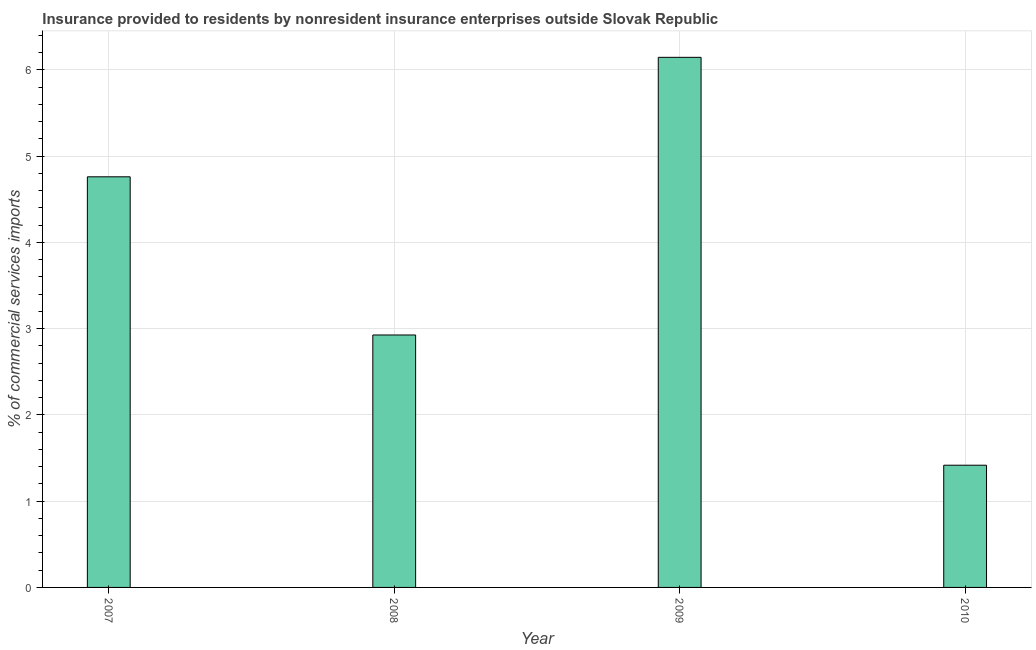Does the graph contain grids?
Keep it short and to the point. Yes. What is the title of the graph?
Your answer should be compact. Insurance provided to residents by nonresident insurance enterprises outside Slovak Republic. What is the label or title of the X-axis?
Ensure brevity in your answer.  Year. What is the label or title of the Y-axis?
Give a very brief answer. % of commercial services imports. What is the insurance provided by non-residents in 2007?
Your answer should be very brief. 4.76. Across all years, what is the maximum insurance provided by non-residents?
Keep it short and to the point. 6.15. Across all years, what is the minimum insurance provided by non-residents?
Ensure brevity in your answer.  1.42. In which year was the insurance provided by non-residents maximum?
Offer a terse response. 2009. What is the sum of the insurance provided by non-residents?
Give a very brief answer. 15.25. What is the difference between the insurance provided by non-residents in 2009 and 2010?
Keep it short and to the point. 4.73. What is the average insurance provided by non-residents per year?
Make the answer very short. 3.81. What is the median insurance provided by non-residents?
Offer a terse response. 3.84. In how many years, is the insurance provided by non-residents greater than 0.6 %?
Give a very brief answer. 4. Do a majority of the years between 2008 and 2010 (inclusive) have insurance provided by non-residents greater than 5.6 %?
Your answer should be compact. No. What is the ratio of the insurance provided by non-residents in 2009 to that in 2010?
Offer a terse response. 4.34. What is the difference between the highest and the second highest insurance provided by non-residents?
Offer a very short reply. 1.39. What is the difference between the highest and the lowest insurance provided by non-residents?
Offer a terse response. 4.73. In how many years, is the insurance provided by non-residents greater than the average insurance provided by non-residents taken over all years?
Offer a very short reply. 2. How many bars are there?
Your response must be concise. 4. Are all the bars in the graph horizontal?
Your answer should be very brief. No. How many years are there in the graph?
Ensure brevity in your answer.  4. What is the % of commercial services imports of 2007?
Your response must be concise. 4.76. What is the % of commercial services imports of 2008?
Your response must be concise. 2.93. What is the % of commercial services imports in 2009?
Your response must be concise. 6.15. What is the % of commercial services imports of 2010?
Your response must be concise. 1.42. What is the difference between the % of commercial services imports in 2007 and 2008?
Offer a terse response. 1.83. What is the difference between the % of commercial services imports in 2007 and 2009?
Keep it short and to the point. -1.39. What is the difference between the % of commercial services imports in 2007 and 2010?
Your response must be concise. 3.34. What is the difference between the % of commercial services imports in 2008 and 2009?
Provide a short and direct response. -3.22. What is the difference between the % of commercial services imports in 2008 and 2010?
Offer a very short reply. 1.51. What is the difference between the % of commercial services imports in 2009 and 2010?
Your response must be concise. 4.73. What is the ratio of the % of commercial services imports in 2007 to that in 2008?
Provide a succinct answer. 1.63. What is the ratio of the % of commercial services imports in 2007 to that in 2009?
Provide a succinct answer. 0.78. What is the ratio of the % of commercial services imports in 2007 to that in 2010?
Provide a succinct answer. 3.36. What is the ratio of the % of commercial services imports in 2008 to that in 2009?
Give a very brief answer. 0.48. What is the ratio of the % of commercial services imports in 2008 to that in 2010?
Your answer should be compact. 2.07. What is the ratio of the % of commercial services imports in 2009 to that in 2010?
Your answer should be compact. 4.34. 